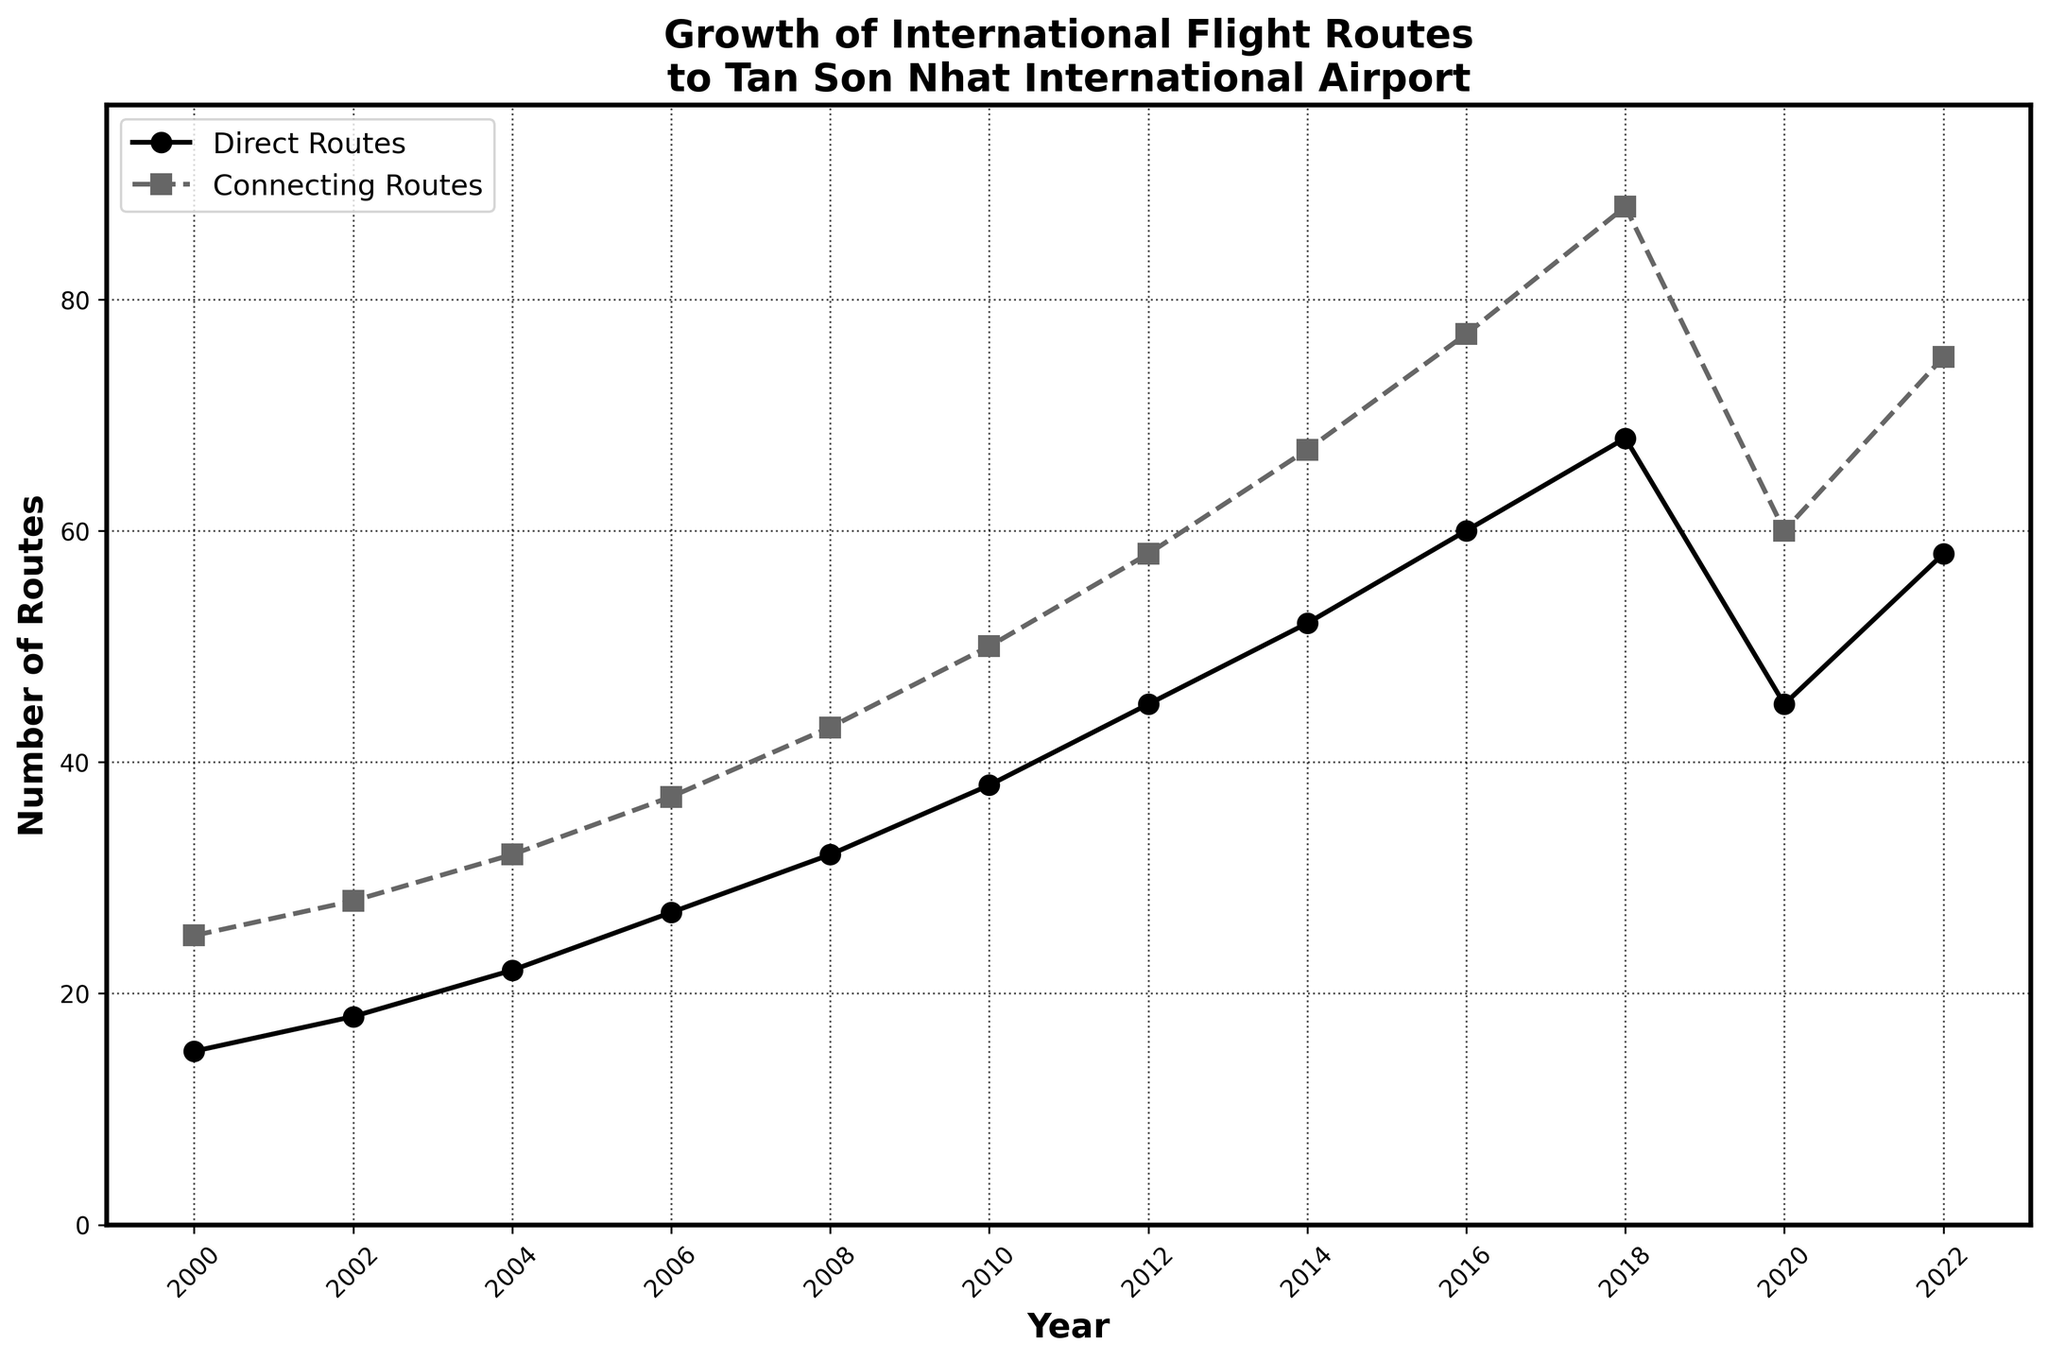What's the total number of Direct and Connecting International Routes in 2018? In 2018, the number of Direct International Routes is 68 and the number of Connecting International Routes is 88. Adding these together gives 68 + 88 = 156.
Answer: 156 Which year saw the highest number of Connecting International Routes? By observing the plot, the highest point on the Connecting International Routes line is at the year 2018, with 88 routes.
Answer: 2018 What is the difference in the number of Direct International Routes between 2016 and 2020? In 2016, the number of Direct International Routes is 60, and in 2020, it is 45. The difference is 60 - 45 = 15.
Answer: 15 How did the number of Direct International Routes change from 2008 to 2012? In 2008, there were 32 Direct International Routes, and by 2012, there were 45 Routes. The change is 45 - 32, which gives an increase of 13 routes.
Answer: Increased by 13 In which period was the growth of Connecting International Routes the fastest? Reviewing the slopes of the Connecting Routes line, the steepest increase occurs between 2016 and 2018, where it rises from 77 to 88, a difference of 11.
Answer: 2016 to 2018 Compare the number of Direct and Connecting International Routes in 2022. Which is greater and by how much? In 2022, the number of Direct International Routes is 58, and the number of Connecting International Routes is 75. Therefore, Connecting Routes are greater by 75 - 58 = 17.
Answer: Connecting Routes by 17 What trend can be observed in the number of Direct International Routes from 2000 to 2018? From 2000 to 2018, the number of Direct International Routes generally increases consistently each year, reaching its peak in 2018.
Answer: Increasing trend How many more Connecting International Routes were there compared to Direct International Routes in 2010? In 2010, there were 50 Connecting International Routes and 38 Direct International Routes. The difference is 50 - 38 = 12.
Answer: 12 Between which consecutive years did Connecting International Routes decrease, and by how much? The Connecting International Routes decreased between 2018 and 2020, from 88 to 60. The decrease is 88 - 60 = 28.
Answer: 2018 to 2020, decreased by 28 What's the average number of Direct International Routes over the entire period shown? The total number of Direct International Routes across all years is 430. There are 12 data points, so the average is 430 / 12 ≈ 35.83.
Answer: 35.83 